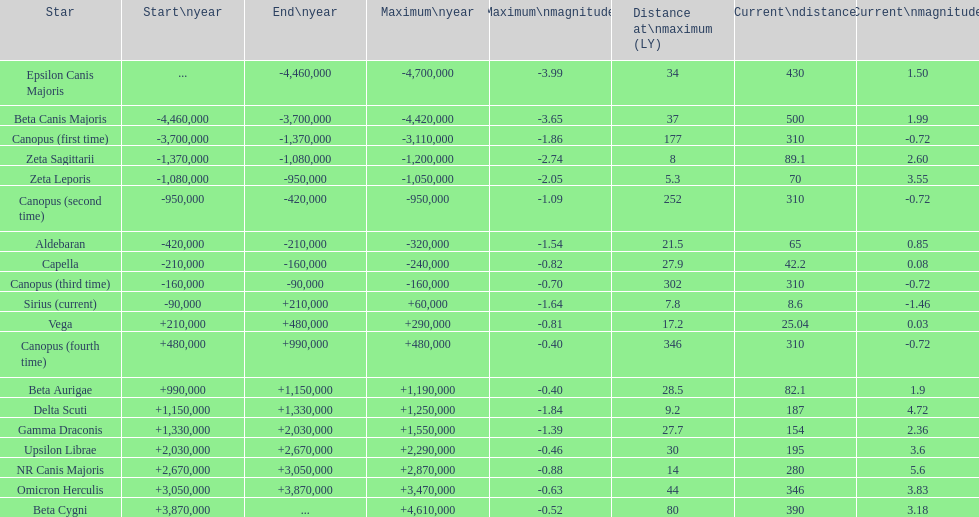Give me the full table as a dictionary. {'header': ['Star', 'Start\\nyear', 'End\\nyear', 'Maximum\\nyear', 'Maximum\\nmagnitude', 'Distance at\\nmaximum (LY)', 'Current\\ndistance', 'Current\\nmagnitude'], 'rows': [['Epsilon Canis Majoris', '...', '-4,460,000', '-4,700,000', '-3.99', '34', '430', '1.50'], ['Beta Canis Majoris', '-4,460,000', '-3,700,000', '-4,420,000', '-3.65', '37', '500', '1.99'], ['Canopus (first time)', '-3,700,000', '-1,370,000', '-3,110,000', '-1.86', '177', '310', '-0.72'], ['Zeta Sagittarii', '-1,370,000', '-1,080,000', '-1,200,000', '-2.74', '8', '89.1', '2.60'], ['Zeta Leporis', '-1,080,000', '-950,000', '-1,050,000', '-2.05', '5.3', '70', '3.55'], ['Canopus (second time)', '-950,000', '-420,000', '-950,000', '-1.09', '252', '310', '-0.72'], ['Aldebaran', '-420,000', '-210,000', '-320,000', '-1.54', '21.5', '65', '0.85'], ['Capella', '-210,000', '-160,000', '-240,000', '-0.82', '27.9', '42.2', '0.08'], ['Canopus (third time)', '-160,000', '-90,000', '-160,000', '-0.70', '302', '310', '-0.72'], ['Sirius (current)', '-90,000', '+210,000', '+60,000', '-1.64', '7.8', '8.6', '-1.46'], ['Vega', '+210,000', '+480,000', '+290,000', '-0.81', '17.2', '25.04', '0.03'], ['Canopus (fourth time)', '+480,000', '+990,000', '+480,000', '-0.40', '346', '310', '-0.72'], ['Beta Aurigae', '+990,000', '+1,150,000', '+1,190,000', '-0.40', '28.5', '82.1', '1.9'], ['Delta Scuti', '+1,150,000', '+1,330,000', '+1,250,000', '-1.84', '9.2', '187', '4.72'], ['Gamma Draconis', '+1,330,000', '+2,030,000', '+1,550,000', '-1.39', '27.7', '154', '2.36'], ['Upsilon Librae', '+2,030,000', '+2,670,000', '+2,290,000', '-0.46', '30', '195', '3.6'], ['NR Canis Majoris', '+2,670,000', '+3,050,000', '+2,870,000', '-0.88', '14', '280', '5.6'], ['Omicron Herculis', '+3,050,000', '+3,870,000', '+3,470,000', '-0.63', '44', '346', '3.83'], ['Beta Cygni', '+3,870,000', '...', '+4,610,000', '-0.52', '80', '390', '3.18']]} How many stars have a distance at maximum of 30 light years or higher? 9. 